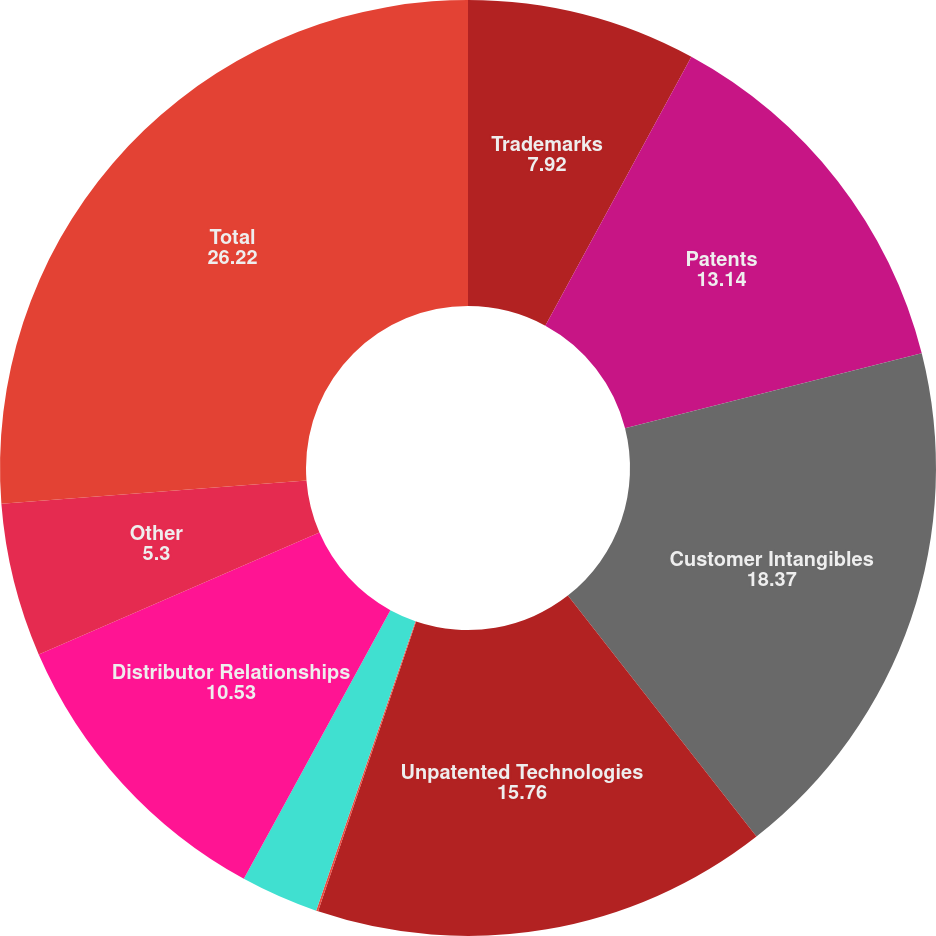<chart> <loc_0><loc_0><loc_500><loc_500><pie_chart><fcel>Trademarks<fcel>Patents<fcel>Customer Intangibles<fcel>Unpatented Technologies<fcel>Non-Compete Agreements<fcel>Drawings & Manuals<fcel>Distributor Relationships<fcel>Other<fcel>Total<nl><fcel>7.92%<fcel>13.14%<fcel>18.37%<fcel>15.76%<fcel>0.07%<fcel>2.69%<fcel>10.53%<fcel>5.3%<fcel>26.22%<nl></chart> 